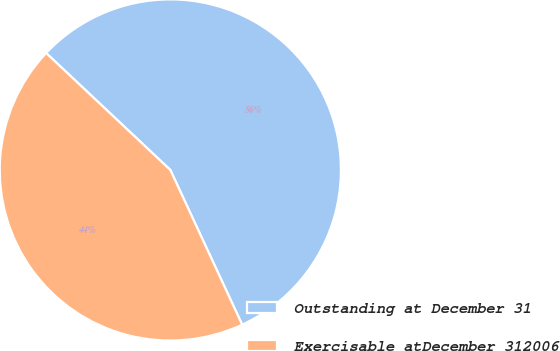Convert chart. <chart><loc_0><loc_0><loc_500><loc_500><pie_chart><fcel>Outstanding at December 31<fcel>Exercisable atDecember 312006<nl><fcel>56.06%<fcel>43.94%<nl></chart> 